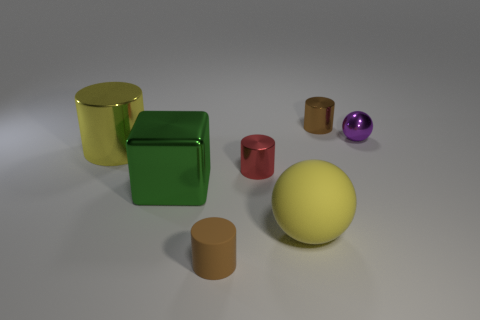Is the number of matte objects to the left of the tiny red thing greater than the number of rubber cylinders that are to the left of the small brown matte cylinder?
Keep it short and to the point. Yes. How many other things are there of the same shape as the tiny purple metal thing?
Your answer should be compact. 1. There is a tiny brown thing that is in front of the brown metallic object; is there a tiny red metallic object that is behind it?
Offer a very short reply. Yes. What number of small yellow objects are there?
Ensure brevity in your answer.  0. Do the shiny cube and the sphere that is in front of the purple ball have the same color?
Ensure brevity in your answer.  No. Are there more yellow metallic cylinders than cyan rubber cubes?
Your answer should be very brief. Yes. Is there any other thing that has the same color as the cube?
Provide a succinct answer. No. What number of other things are there of the same size as the brown rubber object?
Offer a very short reply. 3. There is a ball that is behind the yellow object right of the large shiny thing that is behind the green metallic cube; what is it made of?
Your answer should be very brief. Metal. Is the block made of the same material as the sphere in front of the green cube?
Your answer should be very brief. No. 